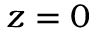Convert formula to latex. <formula><loc_0><loc_0><loc_500><loc_500>z = 0</formula> 